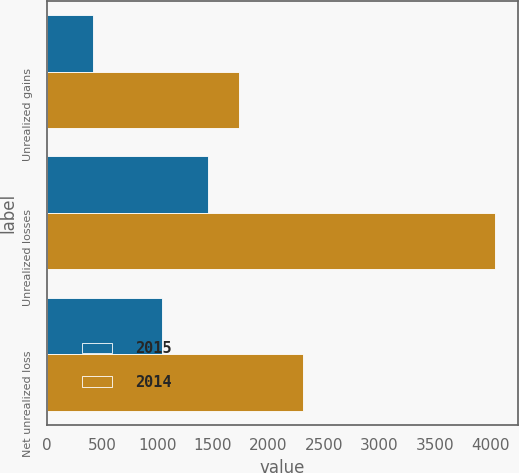<chart> <loc_0><loc_0><loc_500><loc_500><stacked_bar_chart><ecel><fcel>Unrealized gains<fcel>Unrealized losses<fcel>Net unrealized loss<nl><fcel>2015<fcel>416<fcel>1460<fcel>1044<nl><fcel>2014<fcel>1733<fcel>4046<fcel>2313<nl></chart> 